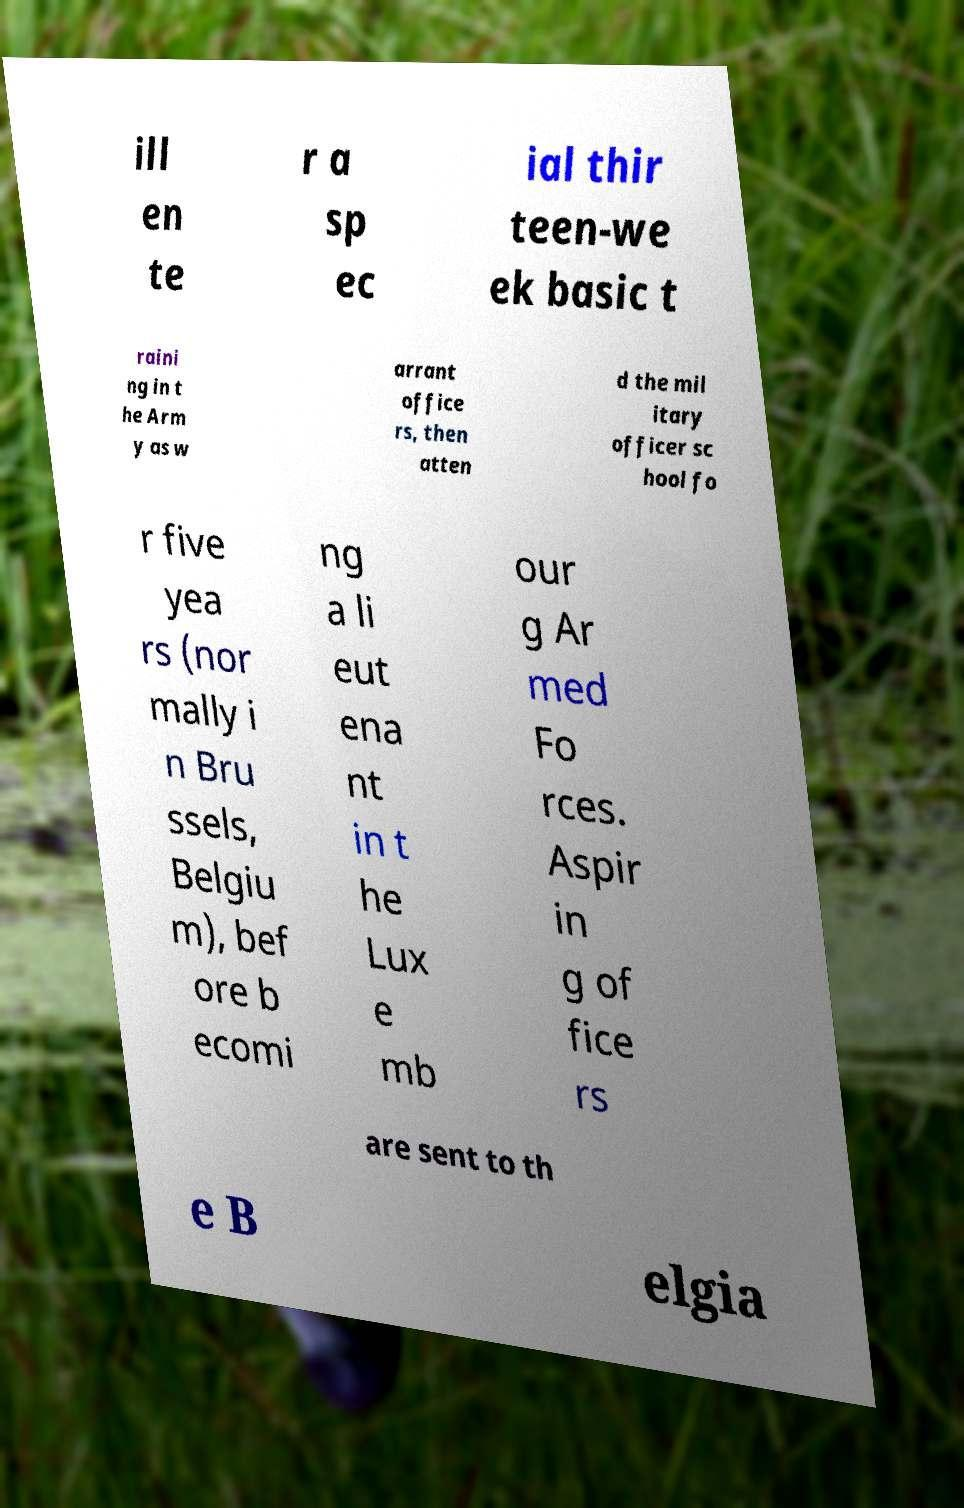Please read and relay the text visible in this image. What does it say? ill en te r a sp ec ial thir teen-we ek basic t raini ng in t he Arm y as w arrant office rs, then atten d the mil itary officer sc hool fo r five yea rs (nor mally i n Bru ssels, Belgiu m), bef ore b ecomi ng a li eut ena nt in t he Lux e mb our g Ar med Fo rces. Aspir in g of fice rs are sent to th e B elgia 